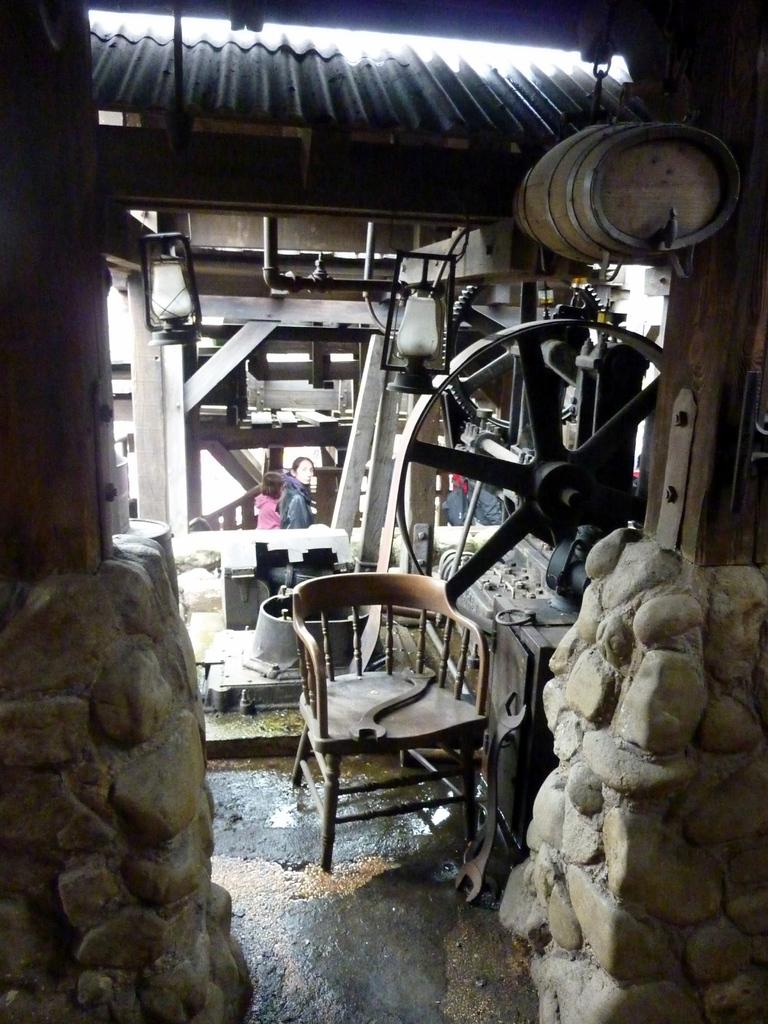What is the main object in the picture? There is a machine in the picture. Are there any furniture items in the picture? Yes, there is a chair in the picture. Who is present in the picture? There is a woman and a girl in the picture. What is the girl doing in the picture? The girl is standing. What type of jeans is the girl wearing in the picture? There is no mention of jeans in the picture, so we cannot determine what type the girl might be wearing. 